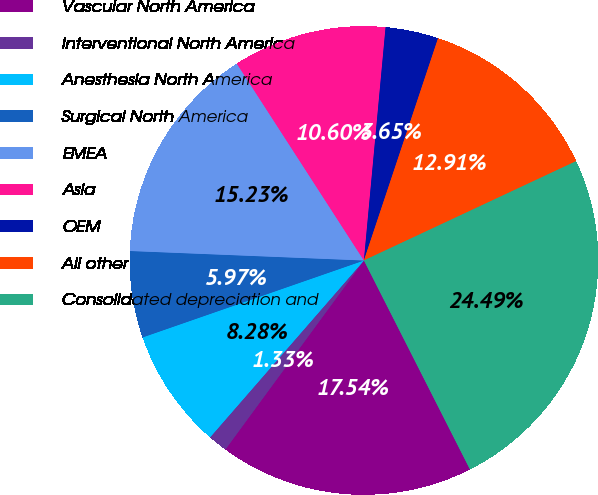Convert chart to OTSL. <chart><loc_0><loc_0><loc_500><loc_500><pie_chart><fcel>Vascular North America<fcel>Interventional North America<fcel>Anesthesia North America<fcel>Surgical North America<fcel>EMEA<fcel>Asia<fcel>OEM<fcel>All other<fcel>Consolidated depreciation and<nl><fcel>17.54%<fcel>1.33%<fcel>8.28%<fcel>5.97%<fcel>15.23%<fcel>10.6%<fcel>3.65%<fcel>12.91%<fcel>24.49%<nl></chart> 